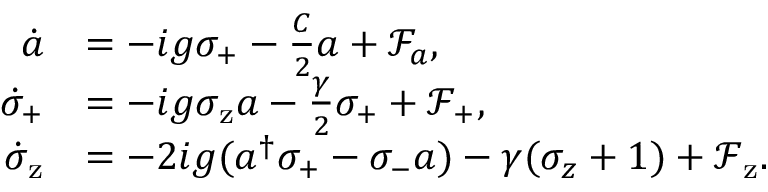Convert formula to latex. <formula><loc_0><loc_0><loc_500><loc_500>\begin{array} { r l } { \dot { a } } & { = - i g \sigma _ { + } - \frac { C } { 2 } a + \mathcal { F } _ { a } , } \\ { \dot { \sigma } _ { + } } & { = - i g \sigma _ { z } a - \frac { \gamma } { 2 } \sigma _ { + } + \mathcal { F } _ { + } , } \\ { \dot { \sigma } _ { z } } & { = - 2 i g ( a ^ { \dagger } \sigma _ { + } - \sigma _ { - } a ) - \gamma ( \sigma _ { z } + 1 ) + \mathcal { F } _ { z } . } \end{array}</formula> 